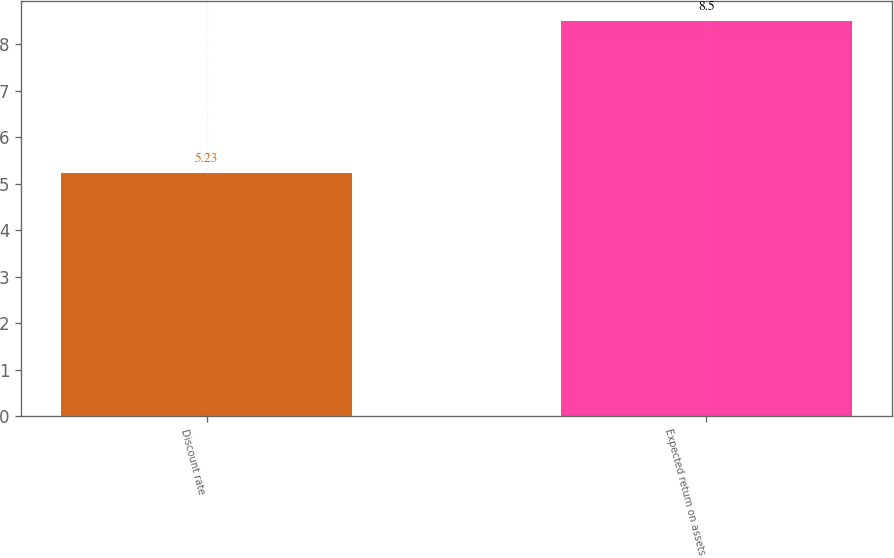<chart> <loc_0><loc_0><loc_500><loc_500><bar_chart><fcel>Discount rate<fcel>Expected return on assets<nl><fcel>5.23<fcel>8.5<nl></chart> 